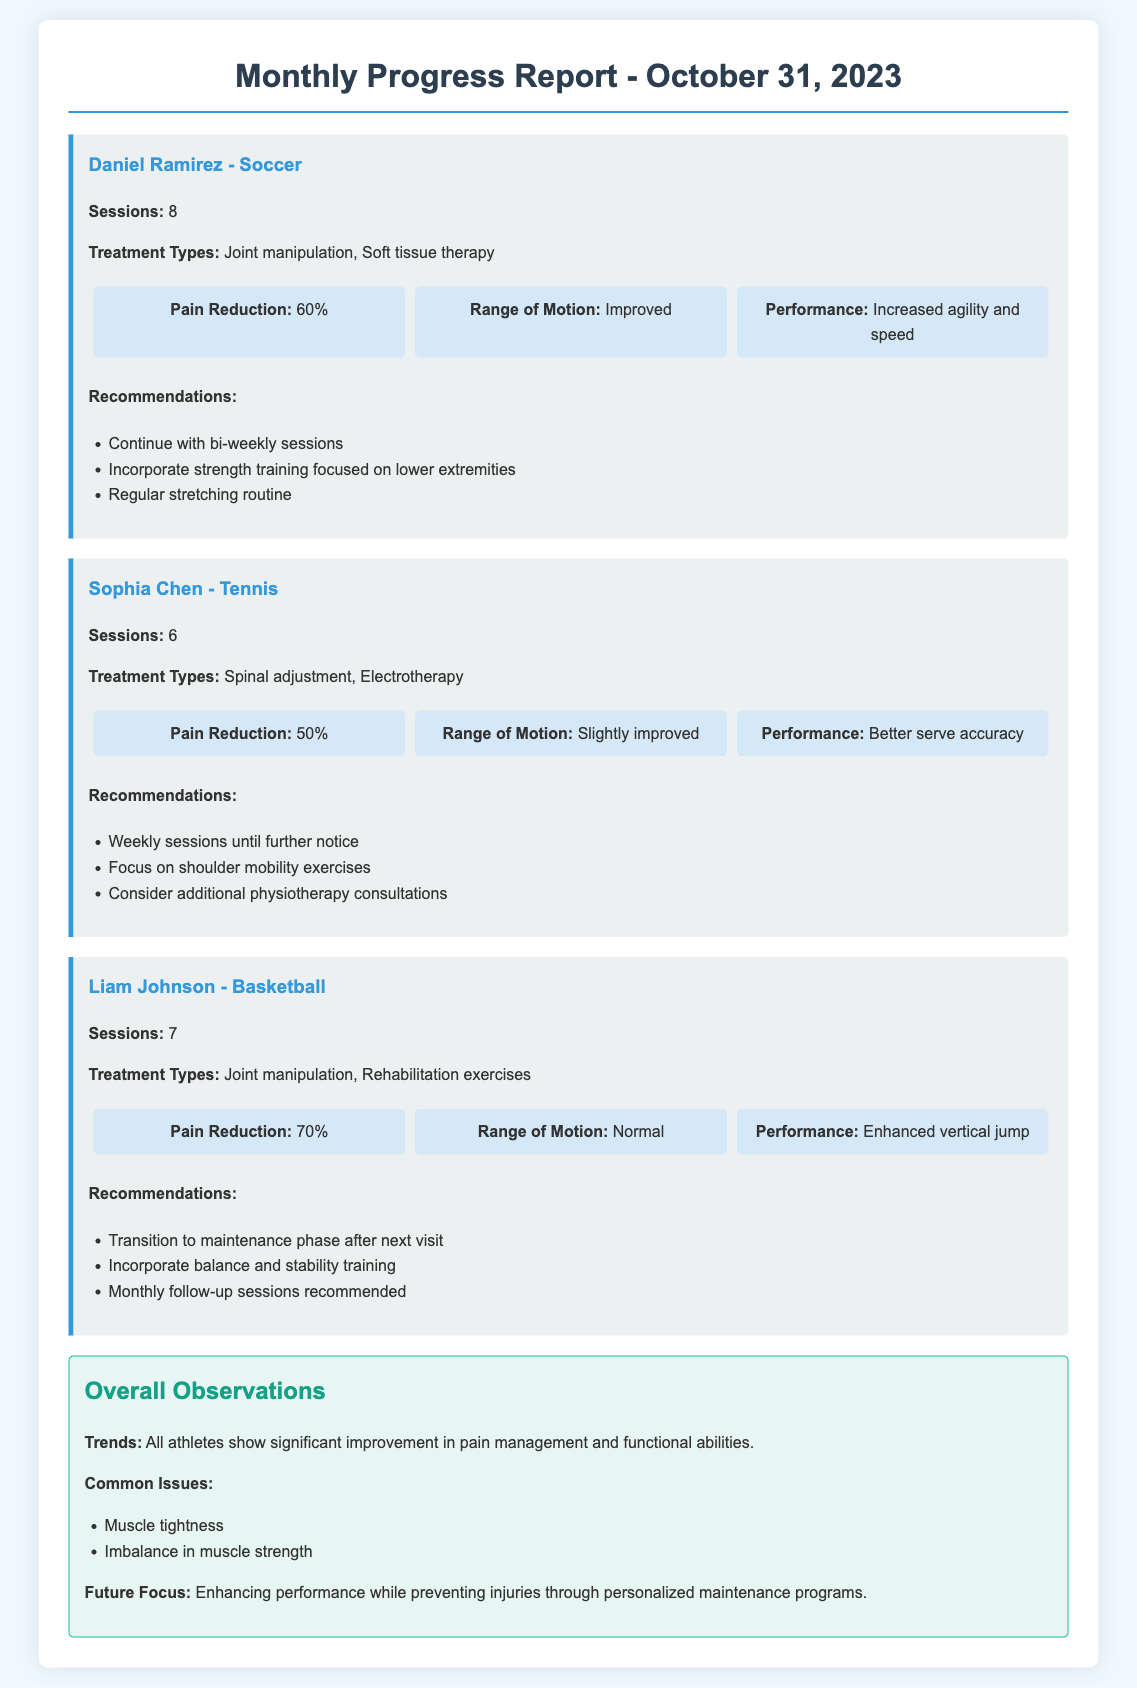What is the total number of sessions for Daniel Ramirez? The total number of sessions for Daniel Ramirez is mentioned as 8 in the report.
Answer: 8 What treatment types did Sophia Chen receive? The treatment types for Sophia Chen include spinal adjustment and electrotherapy, as listed in the document.
Answer: Spinal adjustment, Electrotherapy What percentage of pain reduction did Liam Johnson experience? Liam Johnson's pain reduction is stated as 70%, which is indicated in the outcomes section for him.
Answer: 70% What is the common issue observed among all athletes? The document lists common issues, one of which is muscle tightness; it's mentioned in the overall observations.
Answer: Muscle tightness How many athletes are discussed in the report? The report documents three athletes: Daniel Ramirez, Sophia Chen, and Liam Johnson, indicating the total count is three.
Answer: 3 What was a recommendation for Daniel Ramirez? The document suggests continuing with bi-weekly sessions as a recommendation for Daniel Ramirez.
Answer: Continue with bi-weekly sessions What aspect of Liam Johnson's performance was enhanced? The report states that Liam Johnson experienced an enhanced vertical jump.
Answer: Enhanced vertical jump What was the focus for future programs according to the report? The future focus is described as enhancing performance while preventing injuries through personalized maintenance programs.
Answer: Enhancing performance while preventing injuries 